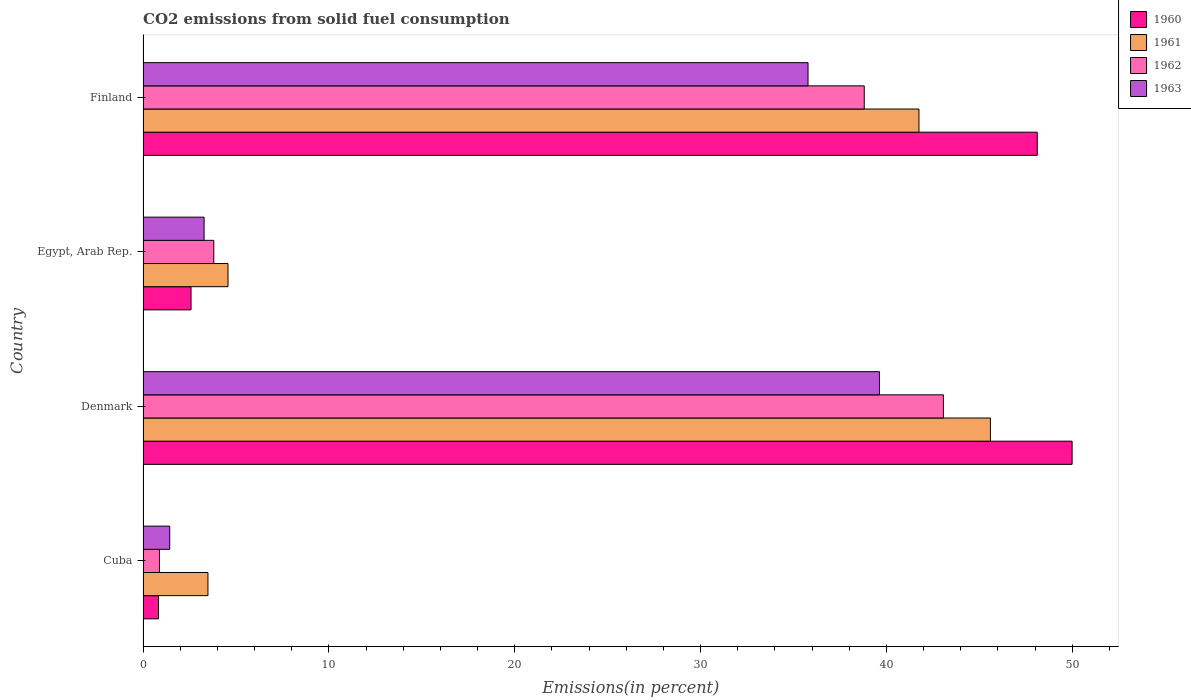Are the number of bars per tick equal to the number of legend labels?
Offer a terse response. Yes. Are the number of bars on each tick of the Y-axis equal?
Your answer should be compact. Yes. How many bars are there on the 3rd tick from the bottom?
Your answer should be very brief. 4. What is the label of the 4th group of bars from the top?
Offer a terse response. Cuba. What is the total CO2 emitted in 1961 in Denmark?
Provide a succinct answer. 45.6. Across all countries, what is the maximum total CO2 emitted in 1960?
Provide a short and direct response. 49.99. Across all countries, what is the minimum total CO2 emitted in 1962?
Your answer should be compact. 0.88. In which country was the total CO2 emitted in 1963 minimum?
Provide a short and direct response. Cuba. What is the total total CO2 emitted in 1961 in the graph?
Keep it short and to the point. 95.41. What is the difference between the total CO2 emitted in 1961 in Denmark and that in Finland?
Give a very brief answer. 3.84. What is the difference between the total CO2 emitted in 1962 in Cuba and the total CO2 emitted in 1960 in Denmark?
Your response must be concise. -49.11. What is the average total CO2 emitted in 1960 per country?
Make the answer very short. 25.38. What is the difference between the total CO2 emitted in 1963 and total CO2 emitted in 1961 in Egypt, Arab Rep.?
Provide a short and direct response. -1.29. What is the ratio of the total CO2 emitted in 1961 in Egypt, Arab Rep. to that in Finland?
Keep it short and to the point. 0.11. What is the difference between the highest and the second highest total CO2 emitted in 1960?
Provide a succinct answer. 1.88. What is the difference between the highest and the lowest total CO2 emitted in 1960?
Offer a very short reply. 49.16. In how many countries, is the total CO2 emitted in 1963 greater than the average total CO2 emitted in 1963 taken over all countries?
Keep it short and to the point. 2. Is it the case that in every country, the sum of the total CO2 emitted in 1962 and total CO2 emitted in 1961 is greater than the sum of total CO2 emitted in 1963 and total CO2 emitted in 1960?
Your response must be concise. No. What does the 3rd bar from the bottom in Egypt, Arab Rep. represents?
Your response must be concise. 1962. Is it the case that in every country, the sum of the total CO2 emitted in 1963 and total CO2 emitted in 1960 is greater than the total CO2 emitted in 1962?
Give a very brief answer. Yes. How many bars are there?
Provide a short and direct response. 16. How many countries are there in the graph?
Provide a short and direct response. 4. What is the difference between two consecutive major ticks on the X-axis?
Offer a very short reply. 10. Are the values on the major ticks of X-axis written in scientific E-notation?
Give a very brief answer. No. Does the graph contain any zero values?
Offer a terse response. No. How are the legend labels stacked?
Offer a terse response. Vertical. What is the title of the graph?
Offer a terse response. CO2 emissions from solid fuel consumption. What is the label or title of the X-axis?
Ensure brevity in your answer.  Emissions(in percent). What is the label or title of the Y-axis?
Your response must be concise. Country. What is the Emissions(in percent) of 1960 in Cuba?
Make the answer very short. 0.83. What is the Emissions(in percent) of 1961 in Cuba?
Ensure brevity in your answer.  3.49. What is the Emissions(in percent) in 1962 in Cuba?
Make the answer very short. 0.88. What is the Emissions(in percent) in 1963 in Cuba?
Provide a succinct answer. 1.43. What is the Emissions(in percent) in 1960 in Denmark?
Offer a very short reply. 49.99. What is the Emissions(in percent) of 1961 in Denmark?
Provide a succinct answer. 45.6. What is the Emissions(in percent) of 1962 in Denmark?
Ensure brevity in your answer.  43.07. What is the Emissions(in percent) in 1963 in Denmark?
Provide a short and direct response. 39.63. What is the Emissions(in percent) in 1960 in Egypt, Arab Rep.?
Your answer should be compact. 2.58. What is the Emissions(in percent) of 1961 in Egypt, Arab Rep.?
Your answer should be very brief. 4.57. What is the Emissions(in percent) in 1962 in Egypt, Arab Rep.?
Your answer should be very brief. 3.81. What is the Emissions(in percent) in 1963 in Egypt, Arab Rep.?
Give a very brief answer. 3.28. What is the Emissions(in percent) in 1960 in Finland?
Offer a terse response. 48.12. What is the Emissions(in percent) in 1961 in Finland?
Your response must be concise. 41.75. What is the Emissions(in percent) of 1962 in Finland?
Offer a very short reply. 38.81. What is the Emissions(in percent) in 1963 in Finland?
Provide a short and direct response. 35.78. Across all countries, what is the maximum Emissions(in percent) in 1960?
Keep it short and to the point. 49.99. Across all countries, what is the maximum Emissions(in percent) of 1961?
Offer a very short reply. 45.6. Across all countries, what is the maximum Emissions(in percent) of 1962?
Offer a very short reply. 43.07. Across all countries, what is the maximum Emissions(in percent) of 1963?
Your answer should be compact. 39.63. Across all countries, what is the minimum Emissions(in percent) in 1960?
Make the answer very short. 0.83. Across all countries, what is the minimum Emissions(in percent) in 1961?
Your answer should be compact. 3.49. Across all countries, what is the minimum Emissions(in percent) of 1962?
Ensure brevity in your answer.  0.88. Across all countries, what is the minimum Emissions(in percent) in 1963?
Ensure brevity in your answer.  1.43. What is the total Emissions(in percent) of 1960 in the graph?
Your answer should be very brief. 101.52. What is the total Emissions(in percent) in 1961 in the graph?
Your answer should be compact. 95.41. What is the total Emissions(in percent) in 1962 in the graph?
Make the answer very short. 86.56. What is the total Emissions(in percent) of 1963 in the graph?
Provide a short and direct response. 80.13. What is the difference between the Emissions(in percent) in 1960 in Cuba and that in Denmark?
Provide a succinct answer. -49.16. What is the difference between the Emissions(in percent) of 1961 in Cuba and that in Denmark?
Your answer should be compact. -42.11. What is the difference between the Emissions(in percent) in 1962 in Cuba and that in Denmark?
Ensure brevity in your answer.  -42.19. What is the difference between the Emissions(in percent) in 1963 in Cuba and that in Denmark?
Offer a very short reply. -38.19. What is the difference between the Emissions(in percent) of 1960 in Cuba and that in Egypt, Arab Rep.?
Your answer should be very brief. -1.75. What is the difference between the Emissions(in percent) in 1961 in Cuba and that in Egypt, Arab Rep.?
Your answer should be compact. -1.08. What is the difference between the Emissions(in percent) in 1962 in Cuba and that in Egypt, Arab Rep.?
Keep it short and to the point. -2.93. What is the difference between the Emissions(in percent) in 1963 in Cuba and that in Egypt, Arab Rep.?
Give a very brief answer. -1.85. What is the difference between the Emissions(in percent) of 1960 in Cuba and that in Finland?
Offer a terse response. -47.29. What is the difference between the Emissions(in percent) of 1961 in Cuba and that in Finland?
Provide a succinct answer. -38.26. What is the difference between the Emissions(in percent) in 1962 in Cuba and that in Finland?
Ensure brevity in your answer.  -37.93. What is the difference between the Emissions(in percent) in 1963 in Cuba and that in Finland?
Your answer should be compact. -34.35. What is the difference between the Emissions(in percent) of 1960 in Denmark and that in Egypt, Arab Rep.?
Your response must be concise. 47.41. What is the difference between the Emissions(in percent) of 1961 in Denmark and that in Egypt, Arab Rep.?
Give a very brief answer. 41.03. What is the difference between the Emissions(in percent) of 1962 in Denmark and that in Egypt, Arab Rep.?
Make the answer very short. 39.26. What is the difference between the Emissions(in percent) of 1963 in Denmark and that in Egypt, Arab Rep.?
Offer a very short reply. 36.34. What is the difference between the Emissions(in percent) of 1960 in Denmark and that in Finland?
Offer a very short reply. 1.88. What is the difference between the Emissions(in percent) of 1961 in Denmark and that in Finland?
Your answer should be very brief. 3.84. What is the difference between the Emissions(in percent) in 1962 in Denmark and that in Finland?
Keep it short and to the point. 4.26. What is the difference between the Emissions(in percent) of 1963 in Denmark and that in Finland?
Your answer should be compact. 3.84. What is the difference between the Emissions(in percent) in 1960 in Egypt, Arab Rep. and that in Finland?
Offer a terse response. -45.54. What is the difference between the Emissions(in percent) of 1961 in Egypt, Arab Rep. and that in Finland?
Make the answer very short. -37.18. What is the difference between the Emissions(in percent) of 1962 in Egypt, Arab Rep. and that in Finland?
Your response must be concise. -35. What is the difference between the Emissions(in percent) in 1963 in Egypt, Arab Rep. and that in Finland?
Give a very brief answer. -32.5. What is the difference between the Emissions(in percent) of 1960 in Cuba and the Emissions(in percent) of 1961 in Denmark?
Your answer should be very brief. -44.77. What is the difference between the Emissions(in percent) in 1960 in Cuba and the Emissions(in percent) in 1962 in Denmark?
Keep it short and to the point. -42.24. What is the difference between the Emissions(in percent) of 1960 in Cuba and the Emissions(in percent) of 1963 in Denmark?
Your answer should be compact. -38.8. What is the difference between the Emissions(in percent) in 1961 in Cuba and the Emissions(in percent) in 1962 in Denmark?
Your response must be concise. -39.58. What is the difference between the Emissions(in percent) in 1961 in Cuba and the Emissions(in percent) in 1963 in Denmark?
Ensure brevity in your answer.  -36.14. What is the difference between the Emissions(in percent) of 1962 in Cuba and the Emissions(in percent) of 1963 in Denmark?
Provide a short and direct response. -38.75. What is the difference between the Emissions(in percent) of 1960 in Cuba and the Emissions(in percent) of 1961 in Egypt, Arab Rep.?
Give a very brief answer. -3.74. What is the difference between the Emissions(in percent) in 1960 in Cuba and the Emissions(in percent) in 1962 in Egypt, Arab Rep.?
Provide a succinct answer. -2.98. What is the difference between the Emissions(in percent) in 1960 in Cuba and the Emissions(in percent) in 1963 in Egypt, Arab Rep.?
Your answer should be compact. -2.45. What is the difference between the Emissions(in percent) in 1961 in Cuba and the Emissions(in percent) in 1962 in Egypt, Arab Rep.?
Offer a terse response. -0.31. What is the difference between the Emissions(in percent) in 1961 in Cuba and the Emissions(in percent) in 1963 in Egypt, Arab Rep.?
Provide a succinct answer. 0.21. What is the difference between the Emissions(in percent) in 1962 in Cuba and the Emissions(in percent) in 1963 in Egypt, Arab Rep.?
Your answer should be very brief. -2.4. What is the difference between the Emissions(in percent) in 1960 in Cuba and the Emissions(in percent) in 1961 in Finland?
Ensure brevity in your answer.  -40.92. What is the difference between the Emissions(in percent) of 1960 in Cuba and the Emissions(in percent) of 1962 in Finland?
Keep it short and to the point. -37.98. What is the difference between the Emissions(in percent) in 1960 in Cuba and the Emissions(in percent) in 1963 in Finland?
Make the answer very short. -34.95. What is the difference between the Emissions(in percent) of 1961 in Cuba and the Emissions(in percent) of 1962 in Finland?
Provide a short and direct response. -35.32. What is the difference between the Emissions(in percent) in 1961 in Cuba and the Emissions(in percent) in 1963 in Finland?
Provide a succinct answer. -32.29. What is the difference between the Emissions(in percent) of 1962 in Cuba and the Emissions(in percent) of 1963 in Finland?
Your response must be concise. -34.9. What is the difference between the Emissions(in percent) of 1960 in Denmark and the Emissions(in percent) of 1961 in Egypt, Arab Rep.?
Provide a succinct answer. 45.42. What is the difference between the Emissions(in percent) of 1960 in Denmark and the Emissions(in percent) of 1962 in Egypt, Arab Rep.?
Provide a succinct answer. 46.19. What is the difference between the Emissions(in percent) of 1960 in Denmark and the Emissions(in percent) of 1963 in Egypt, Arab Rep.?
Offer a very short reply. 46.71. What is the difference between the Emissions(in percent) of 1961 in Denmark and the Emissions(in percent) of 1962 in Egypt, Arab Rep.?
Offer a very short reply. 41.79. What is the difference between the Emissions(in percent) in 1961 in Denmark and the Emissions(in percent) in 1963 in Egypt, Arab Rep.?
Offer a very short reply. 42.31. What is the difference between the Emissions(in percent) in 1962 in Denmark and the Emissions(in percent) in 1963 in Egypt, Arab Rep.?
Your answer should be very brief. 39.79. What is the difference between the Emissions(in percent) of 1960 in Denmark and the Emissions(in percent) of 1961 in Finland?
Make the answer very short. 8.24. What is the difference between the Emissions(in percent) in 1960 in Denmark and the Emissions(in percent) in 1962 in Finland?
Make the answer very short. 11.18. What is the difference between the Emissions(in percent) in 1960 in Denmark and the Emissions(in percent) in 1963 in Finland?
Provide a succinct answer. 14.21. What is the difference between the Emissions(in percent) of 1961 in Denmark and the Emissions(in percent) of 1962 in Finland?
Your answer should be very brief. 6.79. What is the difference between the Emissions(in percent) of 1961 in Denmark and the Emissions(in percent) of 1963 in Finland?
Keep it short and to the point. 9.81. What is the difference between the Emissions(in percent) in 1962 in Denmark and the Emissions(in percent) in 1963 in Finland?
Your response must be concise. 7.29. What is the difference between the Emissions(in percent) of 1960 in Egypt, Arab Rep. and the Emissions(in percent) of 1961 in Finland?
Provide a short and direct response. -39.17. What is the difference between the Emissions(in percent) in 1960 in Egypt, Arab Rep. and the Emissions(in percent) in 1962 in Finland?
Your answer should be very brief. -36.23. What is the difference between the Emissions(in percent) in 1960 in Egypt, Arab Rep. and the Emissions(in percent) in 1963 in Finland?
Your response must be concise. -33.2. What is the difference between the Emissions(in percent) of 1961 in Egypt, Arab Rep. and the Emissions(in percent) of 1962 in Finland?
Ensure brevity in your answer.  -34.24. What is the difference between the Emissions(in percent) in 1961 in Egypt, Arab Rep. and the Emissions(in percent) in 1963 in Finland?
Your answer should be compact. -31.21. What is the difference between the Emissions(in percent) of 1962 in Egypt, Arab Rep. and the Emissions(in percent) of 1963 in Finland?
Your response must be concise. -31.98. What is the average Emissions(in percent) of 1960 per country?
Give a very brief answer. 25.38. What is the average Emissions(in percent) of 1961 per country?
Keep it short and to the point. 23.85. What is the average Emissions(in percent) in 1962 per country?
Your answer should be very brief. 21.64. What is the average Emissions(in percent) in 1963 per country?
Make the answer very short. 20.03. What is the difference between the Emissions(in percent) of 1960 and Emissions(in percent) of 1961 in Cuba?
Your response must be concise. -2.66. What is the difference between the Emissions(in percent) in 1960 and Emissions(in percent) in 1962 in Cuba?
Give a very brief answer. -0.05. What is the difference between the Emissions(in percent) of 1960 and Emissions(in percent) of 1963 in Cuba?
Your response must be concise. -0.6. What is the difference between the Emissions(in percent) of 1961 and Emissions(in percent) of 1962 in Cuba?
Offer a terse response. 2.61. What is the difference between the Emissions(in percent) of 1961 and Emissions(in percent) of 1963 in Cuba?
Give a very brief answer. 2.06. What is the difference between the Emissions(in percent) in 1962 and Emissions(in percent) in 1963 in Cuba?
Offer a very short reply. -0.55. What is the difference between the Emissions(in percent) in 1960 and Emissions(in percent) in 1961 in Denmark?
Your answer should be very brief. 4.4. What is the difference between the Emissions(in percent) in 1960 and Emissions(in percent) in 1962 in Denmark?
Provide a succinct answer. 6.93. What is the difference between the Emissions(in percent) in 1960 and Emissions(in percent) in 1963 in Denmark?
Your answer should be compact. 10.37. What is the difference between the Emissions(in percent) of 1961 and Emissions(in percent) of 1962 in Denmark?
Make the answer very short. 2.53. What is the difference between the Emissions(in percent) in 1961 and Emissions(in percent) in 1963 in Denmark?
Your response must be concise. 5.97. What is the difference between the Emissions(in percent) of 1962 and Emissions(in percent) of 1963 in Denmark?
Offer a very short reply. 3.44. What is the difference between the Emissions(in percent) of 1960 and Emissions(in percent) of 1961 in Egypt, Arab Rep.?
Your answer should be compact. -1.99. What is the difference between the Emissions(in percent) in 1960 and Emissions(in percent) in 1962 in Egypt, Arab Rep.?
Offer a very short reply. -1.22. What is the difference between the Emissions(in percent) in 1960 and Emissions(in percent) in 1963 in Egypt, Arab Rep.?
Offer a very short reply. -0.7. What is the difference between the Emissions(in percent) in 1961 and Emissions(in percent) in 1962 in Egypt, Arab Rep.?
Your response must be concise. 0.76. What is the difference between the Emissions(in percent) in 1961 and Emissions(in percent) in 1963 in Egypt, Arab Rep.?
Offer a terse response. 1.29. What is the difference between the Emissions(in percent) in 1962 and Emissions(in percent) in 1963 in Egypt, Arab Rep.?
Your response must be concise. 0.52. What is the difference between the Emissions(in percent) in 1960 and Emissions(in percent) in 1961 in Finland?
Keep it short and to the point. 6.37. What is the difference between the Emissions(in percent) in 1960 and Emissions(in percent) in 1962 in Finland?
Give a very brief answer. 9.31. What is the difference between the Emissions(in percent) in 1960 and Emissions(in percent) in 1963 in Finland?
Your answer should be compact. 12.34. What is the difference between the Emissions(in percent) in 1961 and Emissions(in percent) in 1962 in Finland?
Offer a very short reply. 2.94. What is the difference between the Emissions(in percent) in 1961 and Emissions(in percent) in 1963 in Finland?
Give a very brief answer. 5.97. What is the difference between the Emissions(in percent) in 1962 and Emissions(in percent) in 1963 in Finland?
Offer a terse response. 3.03. What is the ratio of the Emissions(in percent) of 1960 in Cuba to that in Denmark?
Your response must be concise. 0.02. What is the ratio of the Emissions(in percent) of 1961 in Cuba to that in Denmark?
Your answer should be very brief. 0.08. What is the ratio of the Emissions(in percent) in 1962 in Cuba to that in Denmark?
Make the answer very short. 0.02. What is the ratio of the Emissions(in percent) in 1963 in Cuba to that in Denmark?
Provide a short and direct response. 0.04. What is the ratio of the Emissions(in percent) of 1960 in Cuba to that in Egypt, Arab Rep.?
Give a very brief answer. 0.32. What is the ratio of the Emissions(in percent) in 1961 in Cuba to that in Egypt, Arab Rep.?
Your response must be concise. 0.76. What is the ratio of the Emissions(in percent) of 1962 in Cuba to that in Egypt, Arab Rep.?
Your answer should be compact. 0.23. What is the ratio of the Emissions(in percent) of 1963 in Cuba to that in Egypt, Arab Rep.?
Offer a terse response. 0.44. What is the ratio of the Emissions(in percent) of 1960 in Cuba to that in Finland?
Make the answer very short. 0.02. What is the ratio of the Emissions(in percent) of 1961 in Cuba to that in Finland?
Offer a terse response. 0.08. What is the ratio of the Emissions(in percent) in 1962 in Cuba to that in Finland?
Offer a terse response. 0.02. What is the ratio of the Emissions(in percent) in 1963 in Cuba to that in Finland?
Keep it short and to the point. 0.04. What is the ratio of the Emissions(in percent) of 1960 in Denmark to that in Egypt, Arab Rep.?
Keep it short and to the point. 19.37. What is the ratio of the Emissions(in percent) of 1961 in Denmark to that in Egypt, Arab Rep.?
Provide a succinct answer. 9.98. What is the ratio of the Emissions(in percent) of 1962 in Denmark to that in Egypt, Arab Rep.?
Provide a short and direct response. 11.32. What is the ratio of the Emissions(in percent) of 1963 in Denmark to that in Egypt, Arab Rep.?
Offer a terse response. 12.07. What is the ratio of the Emissions(in percent) of 1960 in Denmark to that in Finland?
Keep it short and to the point. 1.04. What is the ratio of the Emissions(in percent) in 1961 in Denmark to that in Finland?
Keep it short and to the point. 1.09. What is the ratio of the Emissions(in percent) of 1962 in Denmark to that in Finland?
Provide a succinct answer. 1.11. What is the ratio of the Emissions(in percent) of 1963 in Denmark to that in Finland?
Give a very brief answer. 1.11. What is the ratio of the Emissions(in percent) in 1960 in Egypt, Arab Rep. to that in Finland?
Give a very brief answer. 0.05. What is the ratio of the Emissions(in percent) in 1961 in Egypt, Arab Rep. to that in Finland?
Offer a terse response. 0.11. What is the ratio of the Emissions(in percent) of 1962 in Egypt, Arab Rep. to that in Finland?
Ensure brevity in your answer.  0.1. What is the ratio of the Emissions(in percent) of 1963 in Egypt, Arab Rep. to that in Finland?
Ensure brevity in your answer.  0.09. What is the difference between the highest and the second highest Emissions(in percent) in 1960?
Your response must be concise. 1.88. What is the difference between the highest and the second highest Emissions(in percent) in 1961?
Offer a very short reply. 3.84. What is the difference between the highest and the second highest Emissions(in percent) in 1962?
Offer a very short reply. 4.26. What is the difference between the highest and the second highest Emissions(in percent) in 1963?
Offer a very short reply. 3.84. What is the difference between the highest and the lowest Emissions(in percent) of 1960?
Offer a terse response. 49.16. What is the difference between the highest and the lowest Emissions(in percent) in 1961?
Offer a terse response. 42.11. What is the difference between the highest and the lowest Emissions(in percent) in 1962?
Ensure brevity in your answer.  42.19. What is the difference between the highest and the lowest Emissions(in percent) in 1963?
Offer a terse response. 38.19. 